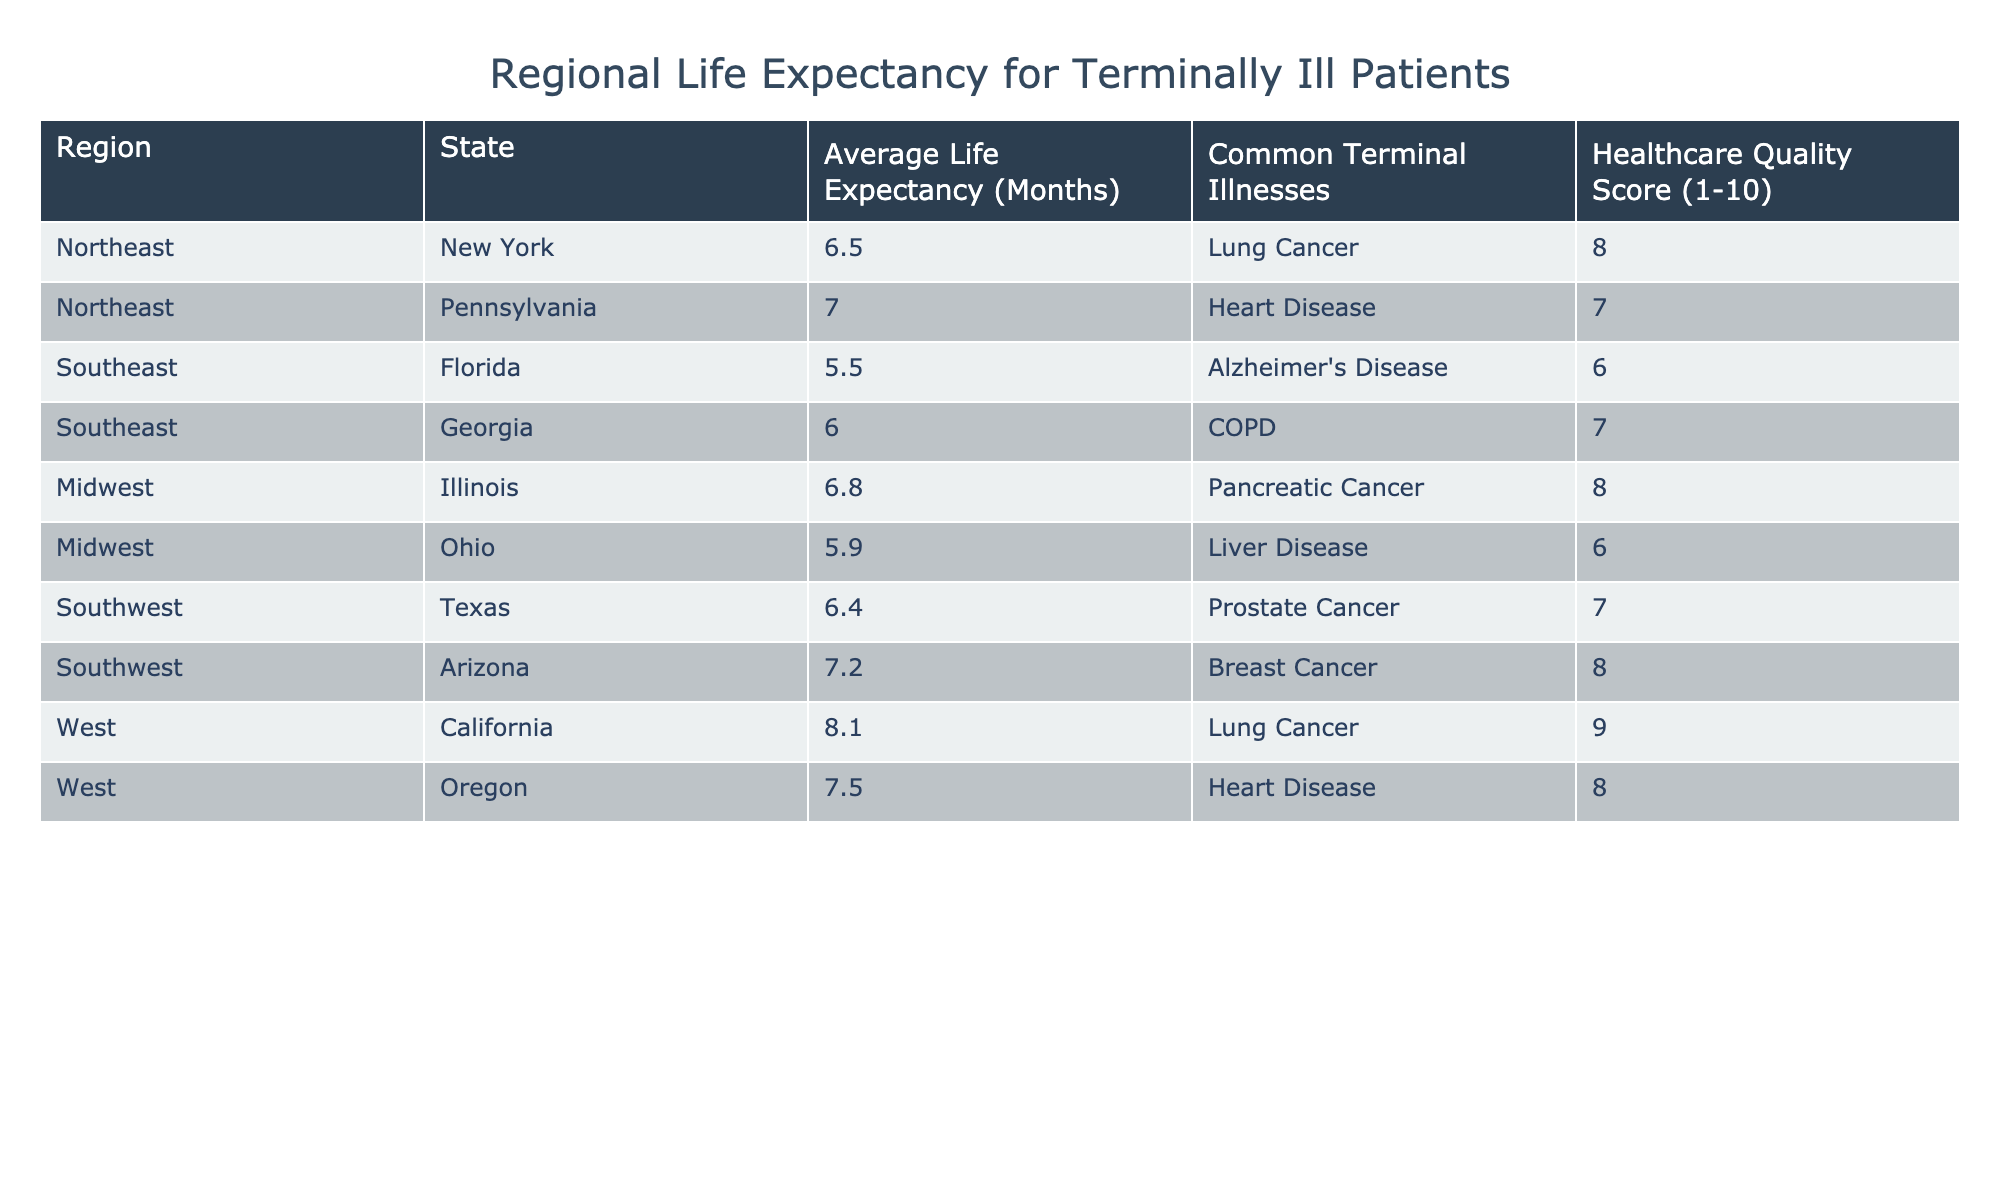What is the average life expectancy for terminally ill patients in California? In the table, the average life expectancy for terminally ill patients in California is listed as 8.1 months.
Answer: 8.1 Which state has the lowest average life expectancy for terminally ill patients? The table shows that Florida has the lowest average life expectancy at 5.5 months, compared to other states listed.
Answer: Florida Is the healthcare quality score for patients in Texas higher than that in Florida? Yes, the table indicates that Texas has a healthcare quality score of 7, while Florida has a score of 6. Therefore, Texas's score is higher.
Answer: Yes What is the average life expectancy for terminally ill patients across all regions? To find the average life expectancy, sum all the average life expectancies (6.5 + 7.0 + 5.5 + 6.0 + 6.8 + 5.9 + 6.4 + 7.2 + 8.1 + 7.5 = 63.5), then divide by the number of states (10). Hence, 63.5 / 10 = 6.35 months, which is the average life expectancy.
Answer: 6.35 Do terminally ill patients in the Midwest have a longer average life expectancy than those in the Southwest? In the Midwest, the average life expectancies are 6.8 months for Illinois and 5.9 months for Ohio, which gives an average of (6.8 + 5.9) / 2 = 6.35 months. In the Southwest, Texas has 6.4 months and Arizona has 7.2 months, yielding an average of (6.4 + 7.2) / 2 = 6.8 months. Since 6.80 months (Southwest) is greater than 6.35 months (Midwest), the statement is true.
Answer: Yes Which common terminal illness has the highest average life expectancy and what is that expectancy? Lung cancer is present in two states: New York with 6.5 months and California with 8.1 months. The highest average is thus calculated as (6.5 + 8.1) / 2 = 7.3 months. California's expectancy is higher than New York's for lung cancer.
Answer: 7.3 Is the average life expectancy for terminally ill patients with Alzheimer's disease lower than that for patients with breast cancer? In the table, the average life expectancy for patients with Alzheimer's disease in Florida is 5.5 months, while for breast cancer in Arizona it is 7.2 months. Since 5.5 is indeed lower than 7.2, the statement is true.
Answer: Yes 